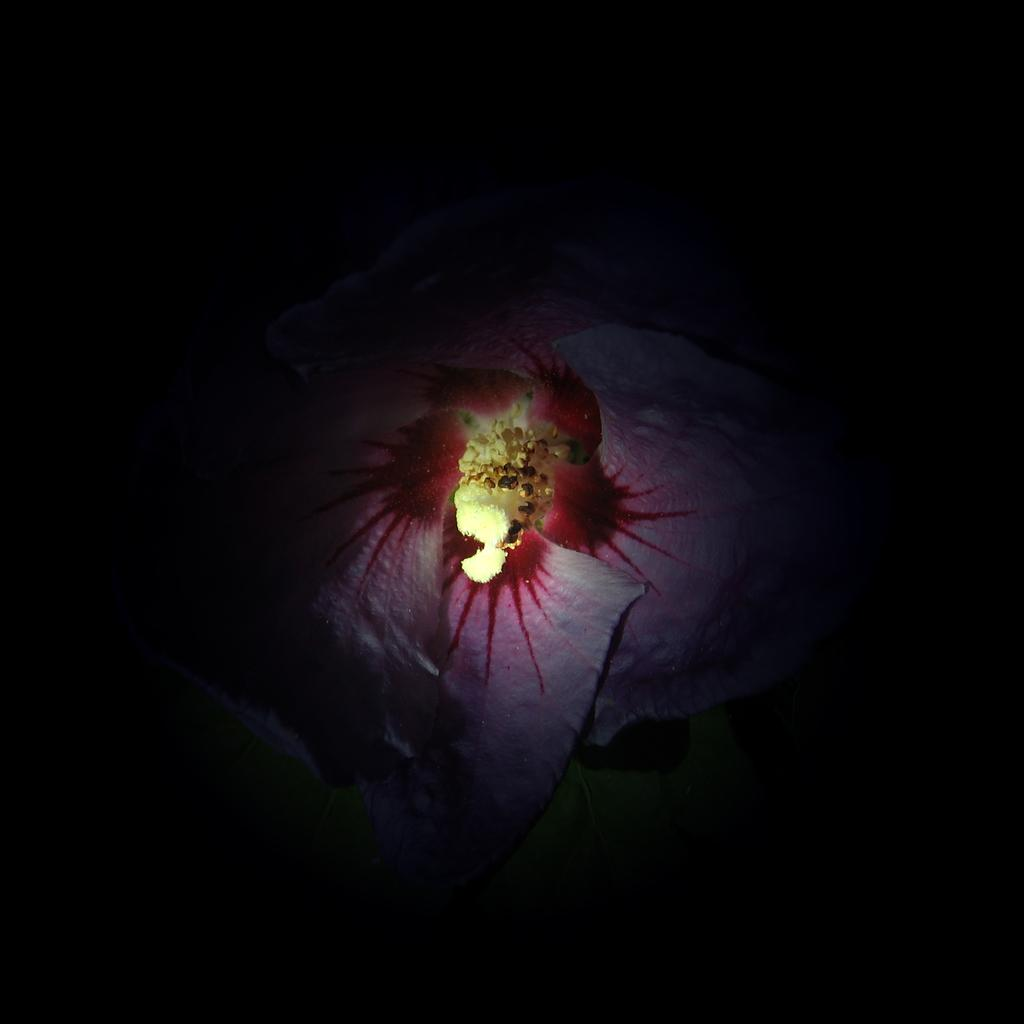What is the main object in the image? There is a cloth in the image. What colors are present on the cloth? The cloth has red and white colors. What can be observed about the background of the image? The background of the image is dark. How many mice are hiding under the cloth in the image? There are no mice present in the image; it only features a cloth with red and white colors against a dark background. 